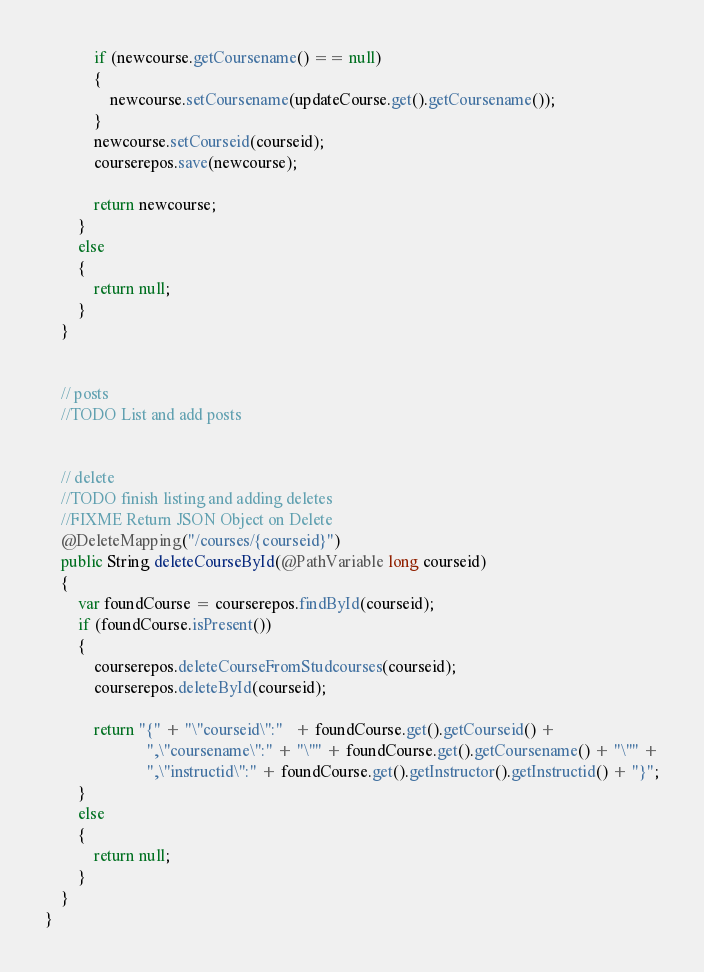Convert code to text. <code><loc_0><loc_0><loc_500><loc_500><_Java_>            if (newcourse.getCoursename() == null)
            {
                newcourse.setCoursename(updateCourse.get().getCoursename());
            }
            newcourse.setCourseid(courseid);
            courserepos.save(newcourse);

            return newcourse;
        }
        else
        {
            return null;
        }
    }


    // posts
    //TODO List and add posts


    // delete
    //TODO finish listing and adding deletes
    //FIXME Return JSON Object on Delete
    @DeleteMapping("/courses/{courseid}")
    public String deleteCourseById(@PathVariable long courseid)
    {
        var foundCourse = courserepos.findById(courseid);
        if (foundCourse.isPresent())
        {
            courserepos.deleteCourseFromStudcourses(courseid);
            courserepos.deleteById(courseid);

            return "{" + "\"courseid\":"   + foundCourse.get().getCourseid() +
                         ",\"coursename\":" + "\"" + foundCourse.get().getCoursename() + "\"" +
                         ",\"instructid\":" + foundCourse.get().getInstructor().getInstructid() + "}";
        }
        else
        {
            return null;
        }
    }
}
</code> 